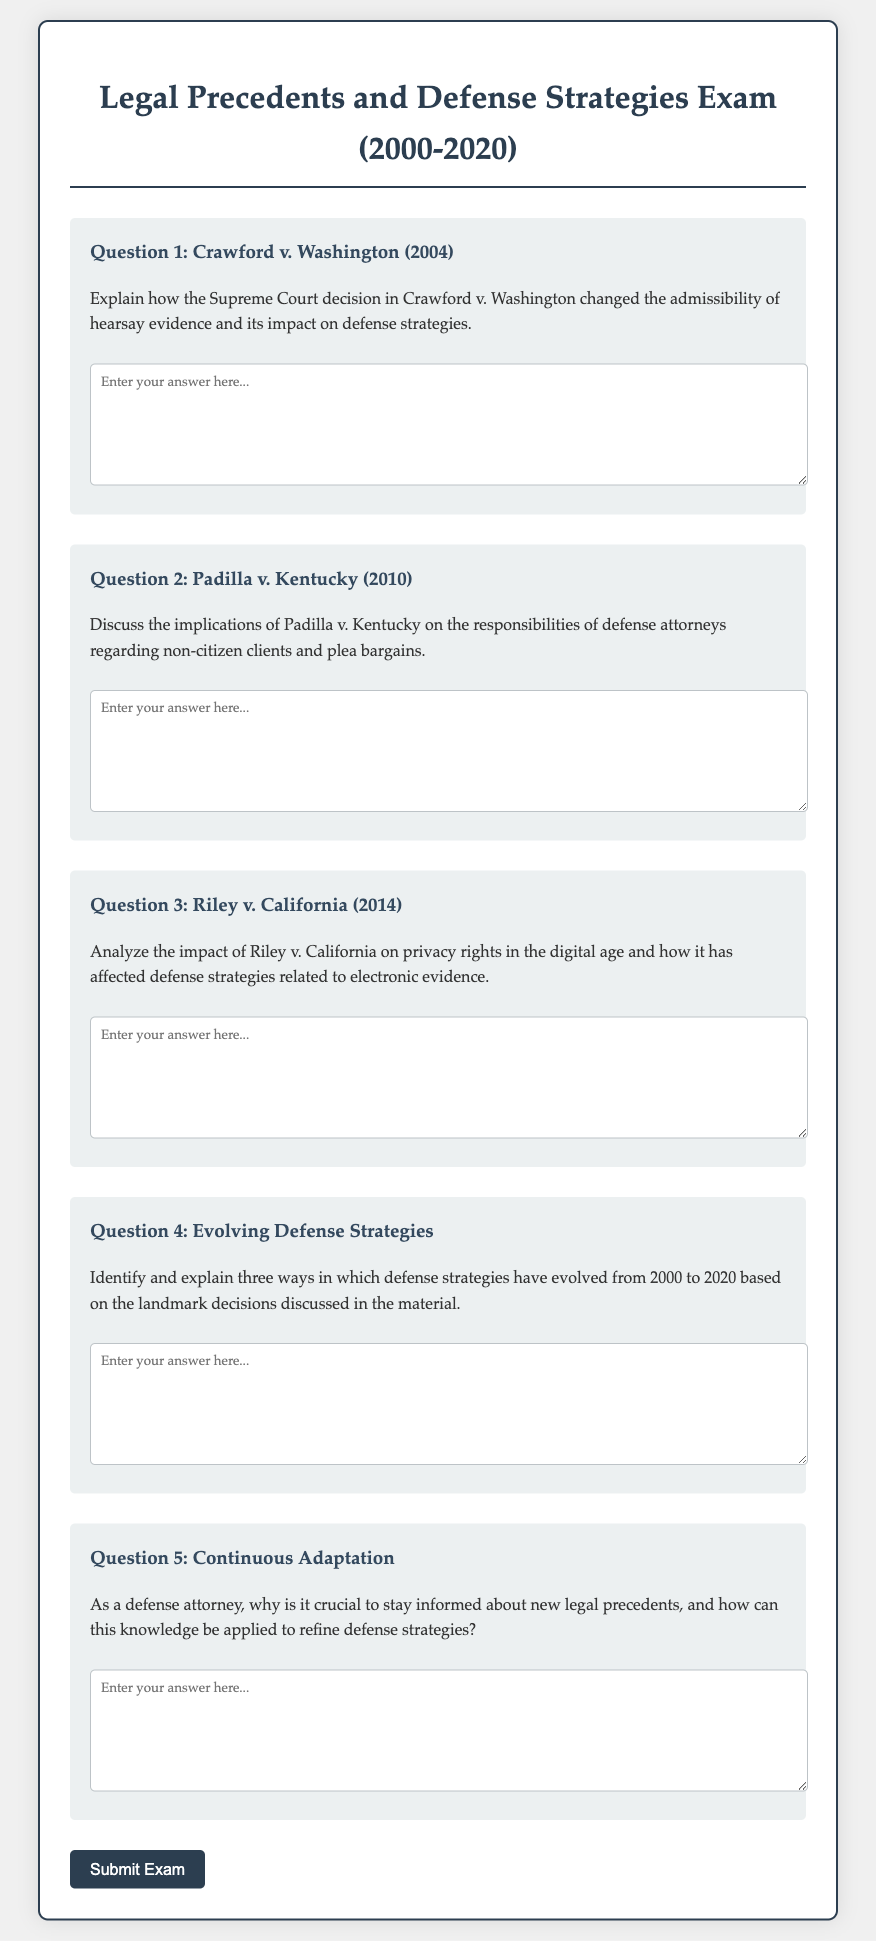What is the title of the exam? The title of the exam is presented in the header of the document, which states "Legal Precedents and Defense Strategies Exam (2000-2020)".
Answer: Legal Precedents and Defense Strategies Exam (2000-2020) What case is referenced in Question 1? The case referenced in Question 1 is identified under the title stating "Crawford v. Washington (2004)".
Answer: Crawford v. Washington What year was Padilla v. Kentucky decided? The year Padilla v. Kentucky was decided is mentioned in the title of Question 2 as "Padilla v. Kentucky (2010)".
Answer: 2010 How many questions are included in the exam? The number of questions in the exam can be counted from the document, and there are a total of five questions presented.
Answer: 5 What is the main focus of the exam questions? The main focus of the exam questions revolves around analyzing the influence of legal precedents on defense strategies.
Answer: Legal precedents on defense strategies In which question is the topic of privacy rights addressed? The topic of privacy rights is addressed in Question 3, which is about "Riley v. California (2014)".
Answer: Question 3 What is the overarching theme of Question 4? The overarching theme of Question 4 is the evolution of defense strategies from 2000 to 2020.
Answer: Evolution of defense strategies What type of document is this? This document is an exam specifically designed for evaluating knowledge on legal precedents and their influence on defense strategies.
Answer: Exam 